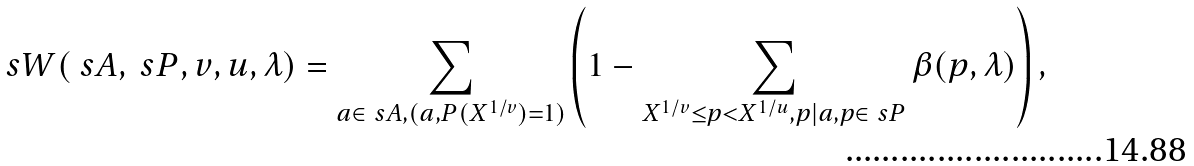Convert formula to latex. <formula><loc_0><loc_0><loc_500><loc_500>\ s W ( \ s A , \ s P , v , u , \lambda ) = \sum _ { a \in \ s A , ( a , P ( X ^ { 1 / v } ) = 1 ) } \left ( 1 - \sum _ { X ^ { 1 / v } \leq p < X ^ { 1 / u } , p | a , p \in \ s P } \beta ( p , \lambda ) \right ) ,</formula> 